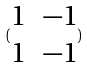<formula> <loc_0><loc_0><loc_500><loc_500>( \begin{matrix} 1 & - 1 \\ 1 & - 1 \end{matrix} )</formula> 